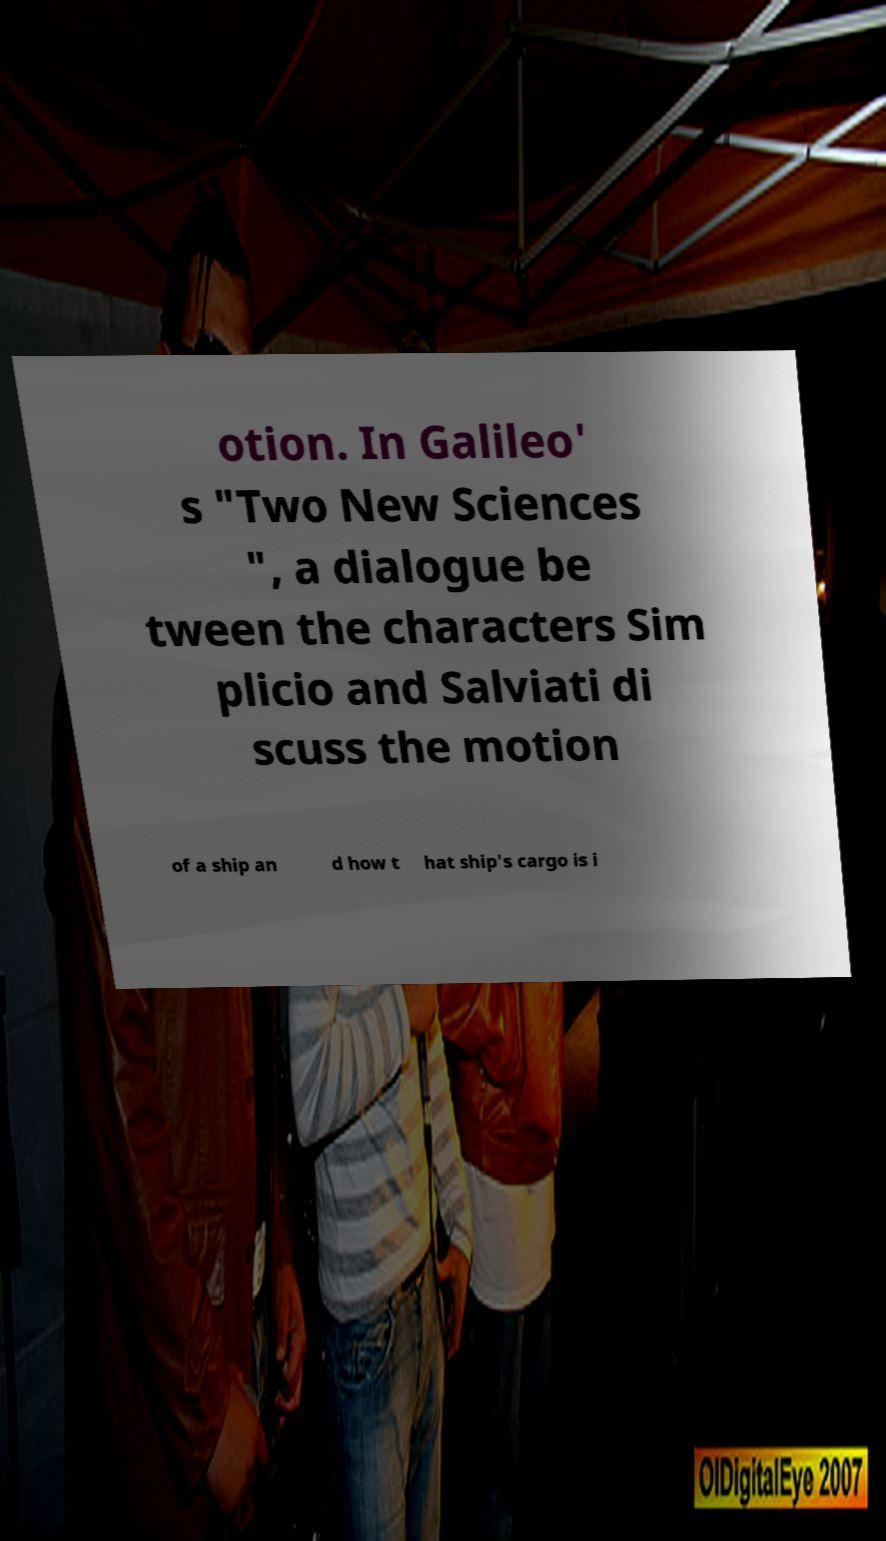There's text embedded in this image that I need extracted. Can you transcribe it verbatim? otion. In Galileo' s "Two New Sciences ", a dialogue be tween the characters Sim plicio and Salviati di scuss the motion of a ship an d how t hat ship's cargo is i 